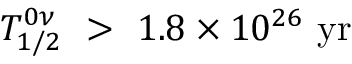Convert formula to latex. <formula><loc_0><loc_0><loc_500><loc_500>T _ { 1 / 2 } ^ { 0 \nu } \ > \ { 1 . 8 } \times 1 0 ^ { 2 6 } \ y r</formula> 